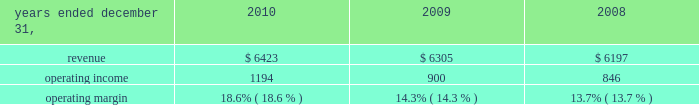Considered to be the primary beneficiary of either entity and have therefore deconsolidated both entities .
At december 31 , 2010 , we held a 36% ( 36 % ) interest in juniperus which is accounted for using the equity method of accounting .
Our potential loss at december 31 , 2010 is limited to our investment of $ 73 million in juniperus , which is recorded in investments in the consolidated statements of financial position .
We have not provided any financing to juniperus other than previously contractually required amounts .
Juniperus and jchl had combined assets and liabilities of $ 121 million and $ 22 million , respectively , at december 31 , 2008 .
For the year ended december 31 , 2009 , we recognized $ 36 million of pretax income from juniperus and jchl .
We recognized $ 16 million of after-tax income , after allocating the appropriate share of net income to the non-controlling interests .
We previously owned an 85% ( 85 % ) economic equity interest in globe re limited ( 2018 2018globe re 2019 2019 ) , a vie , which provided reinsurance coverage for a defined portfolio of property catastrophe reinsurance contracts underwritten by a third party for a limited period which ended june 1 , 2009 .
We consolidated globe re as we were deemed to be the primary beneficiary .
In connection with the winding up of its operations , globe re repaid its $ 100 million of short-term debt and our equity investment from available cash in 2009 .
We recognized $ 2 million of after-tax income from globe re in 2009 , taking into account the share of net income attributable to non-controlling interests .
Globe re was fully liquidated in the third quarter of 2009 .
Review by segment general we serve clients through the following segments : 2022 risk solutions ( formerly risk and insurance brokerage services ) acts as an advisor and insurance and reinsurance broker , helping clients manage their risks , via consultation , as well as negotiation and placement of insurance risk with insurance carriers through our global distribution network .
2022 hr solutions ( formerly consulting ) partners with organizations to solve their most complex benefits , talent and related financial challenges , and improve business performance by designing , implementing , communicating and administering a wide range of human capital , retirement , investment management , health care , compensation and talent management strategies .
Risk solutions .
The demand for property and casualty insurance generally rises as the overall level of economic activity increases and generally falls as such activity decreases , affecting both the commissions and fees generated by our brokerage business .
The economic activity that impacts property and casualty insurance is described as exposure units , and is most closely correlated with employment levels , corporate revenue and asset values .
During 2010 we continued to see a 2018 2018soft market 2019 2019 , which began in 2007 , in our retail brokerage product line .
In a soft market , premium rates flatten or decrease , along with commission revenues , due to increased competition for market share among insurance carriers or increased underwriting capacity .
Changes in premiums have a direct and potentially material impact on the insurance brokerage industry , as commission revenues are generally based on a percentage of the .
What are the total operating expenses for 2015? 
Computations: (6423 - 1194)
Answer: 5229.0. 